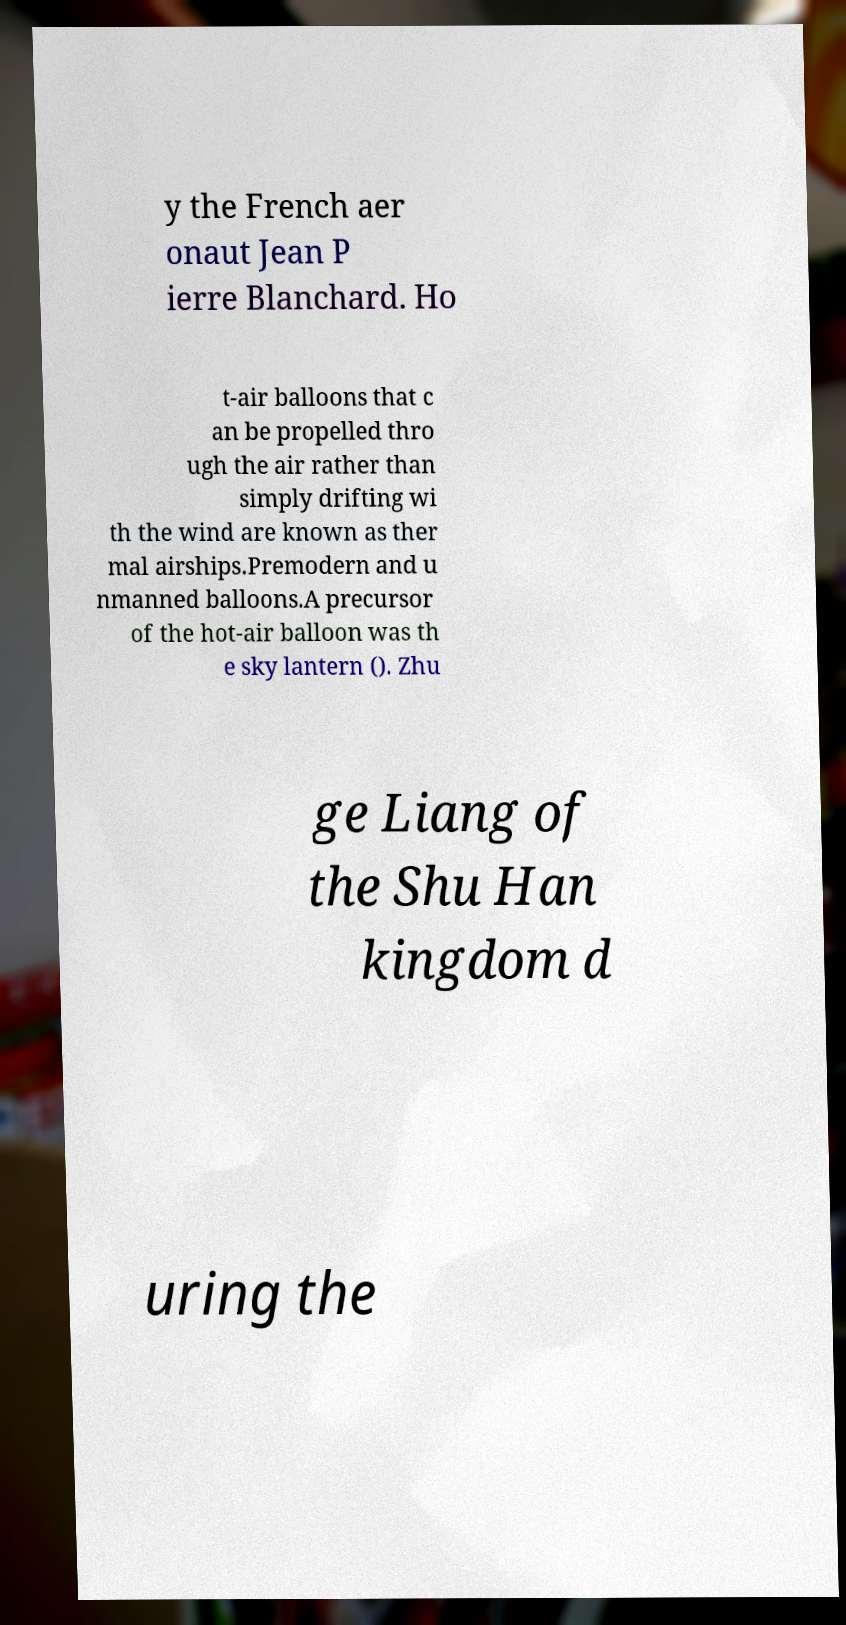Could you assist in decoding the text presented in this image and type it out clearly? y the French aer onaut Jean P ierre Blanchard. Ho t-air balloons that c an be propelled thro ugh the air rather than simply drifting wi th the wind are known as ther mal airships.Premodern and u nmanned balloons.A precursor of the hot-air balloon was th e sky lantern (). Zhu ge Liang of the Shu Han kingdom d uring the 